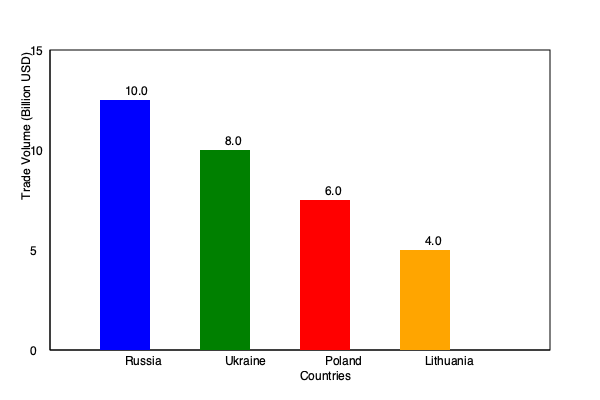Based on the bar chart depicting Belarus's trade volumes with neighboring countries, calculate the percentage of Belarus's total trade volume represented by its trade with Russia. How might this level of trade dependency on Russia impact Belarus's economic stability and regional influence? To answer this question, we need to follow these steps:

1. Calculate the total trade volume:
   Russia: $10.0 billion
   Ukraine: $8.0 billion
   Poland: $6.0 billion
   Lithuania: $4.0 billion
   Total = $10.0 + $8.0 + $6.0 + $4.0 = $28.0 billion

2. Calculate the percentage of trade with Russia:
   Percentage = (Russian trade volume / Total trade volume) * 100
   = ($10.0 billion / $28.0 billion) * 100
   = 0.3571 * 100 = 35.71%

3. Analyze the impact:
   a) Economic stability:
      - High dependence (35.71%) on a single trading partner increases vulnerability to economic shocks.
      - Any political tensions or economic downturns in Russia could significantly impact Belarus's economy.
      - Limited diversification of trade partners may hinder economic resilience.

   b) Regional influence:
      - Strong economic ties with Russia may limit Belarus's ability to act independently in regional matters.
      - Other neighboring countries might view Belarus as closely aligned with Russian interests.
      - Belarus's bargaining power in regional negotiations could be compromised due to its economic reliance on Russia.

4. Consider potential strategies:
   - Diversifying trade partners to reduce dependency on Russia.
   - Developing industries that can compete in markets beyond the immediate region.
   - Balancing economic ties with political independence to maintain regional stability.

The high percentage of trade with Russia (35.71%) suggests a significant economic dependency, which could potentially limit Belarus's economic stability and regional influence due to overreliance on a single partner.
Answer: 35.71%; high economic dependency on Russia likely limits Belarus's economic stability and regional influence. 